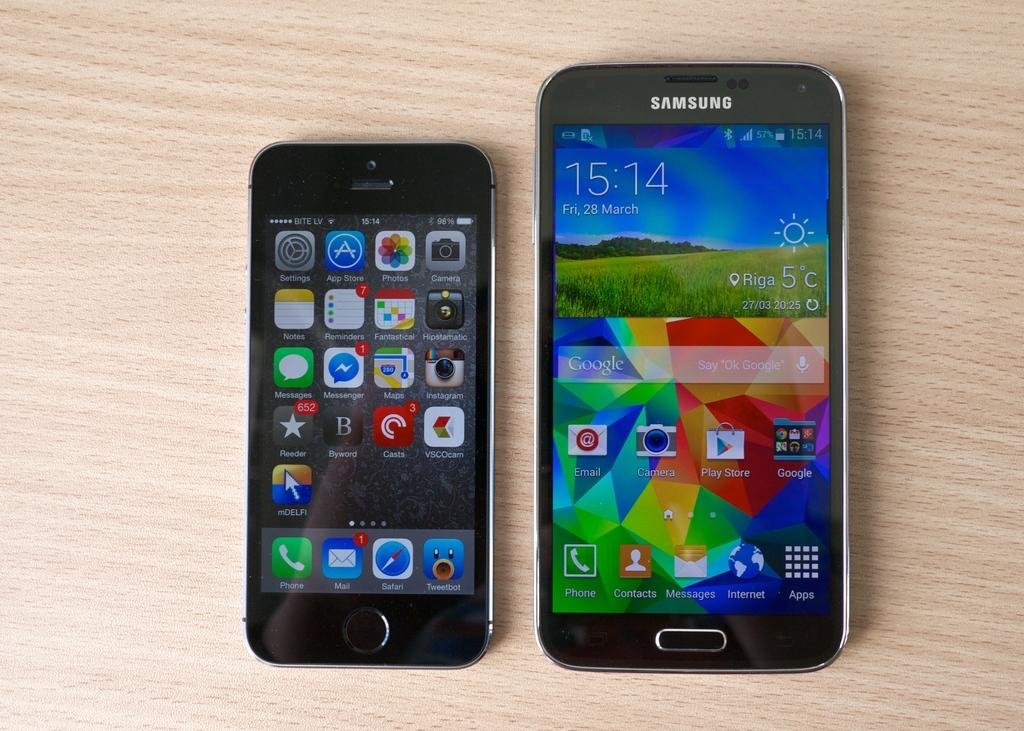<image>
Describe the image concisely. Two phones, the one on the right being a Samsung. 